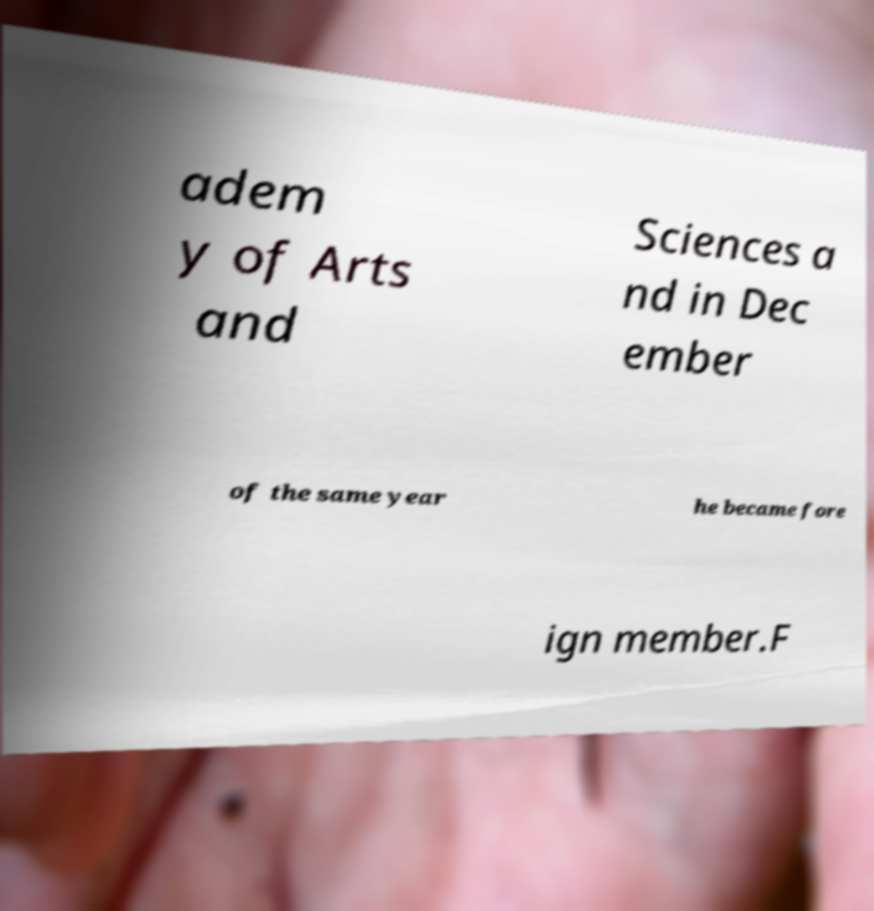I need the written content from this picture converted into text. Can you do that? adem y of Arts and Sciences a nd in Dec ember of the same year he became fore ign member.F 